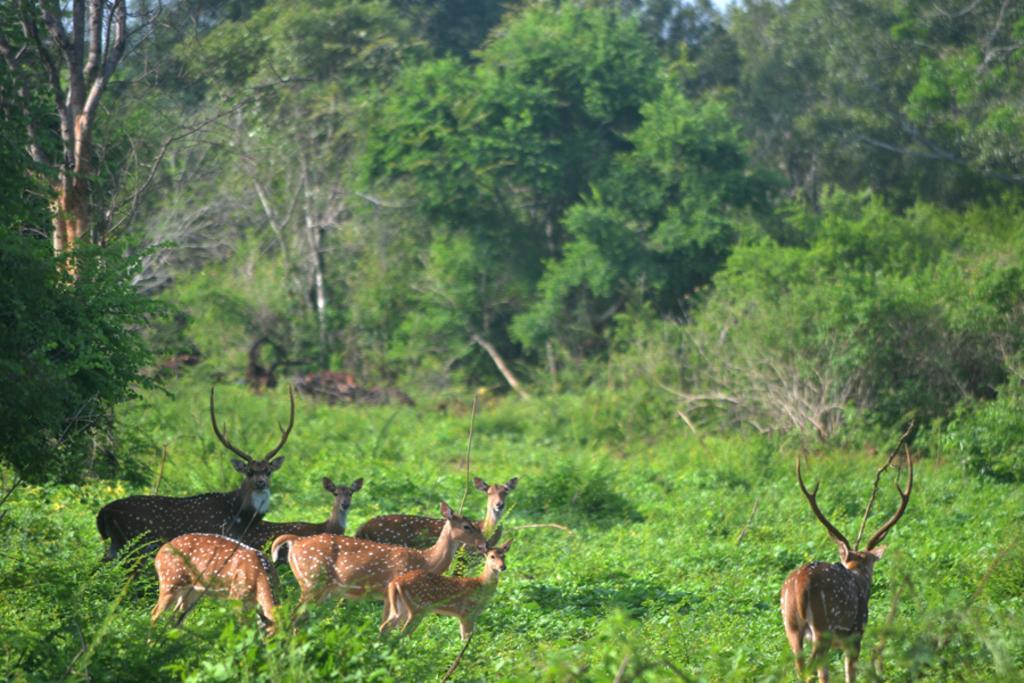In one or two sentences, can you explain what this image depicts? In this image I can see the animals. In the background, I can see the trees. 